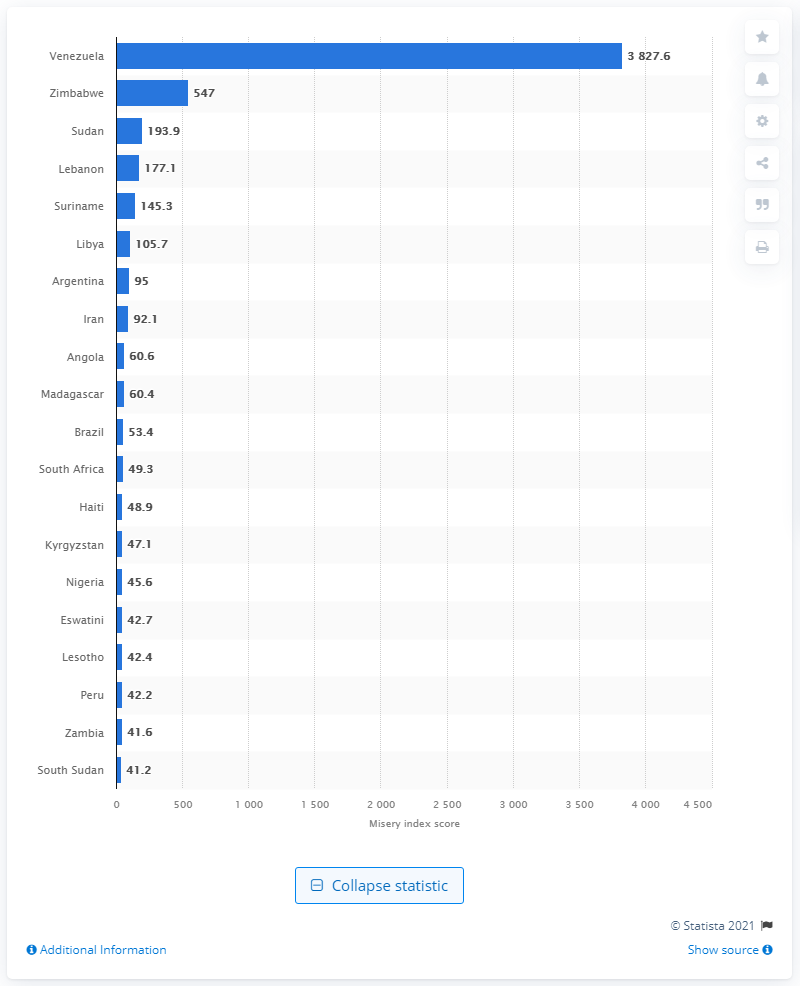Specify some key components in this picture. In 2020, Venezuela was considered the most miserable country in the world. 